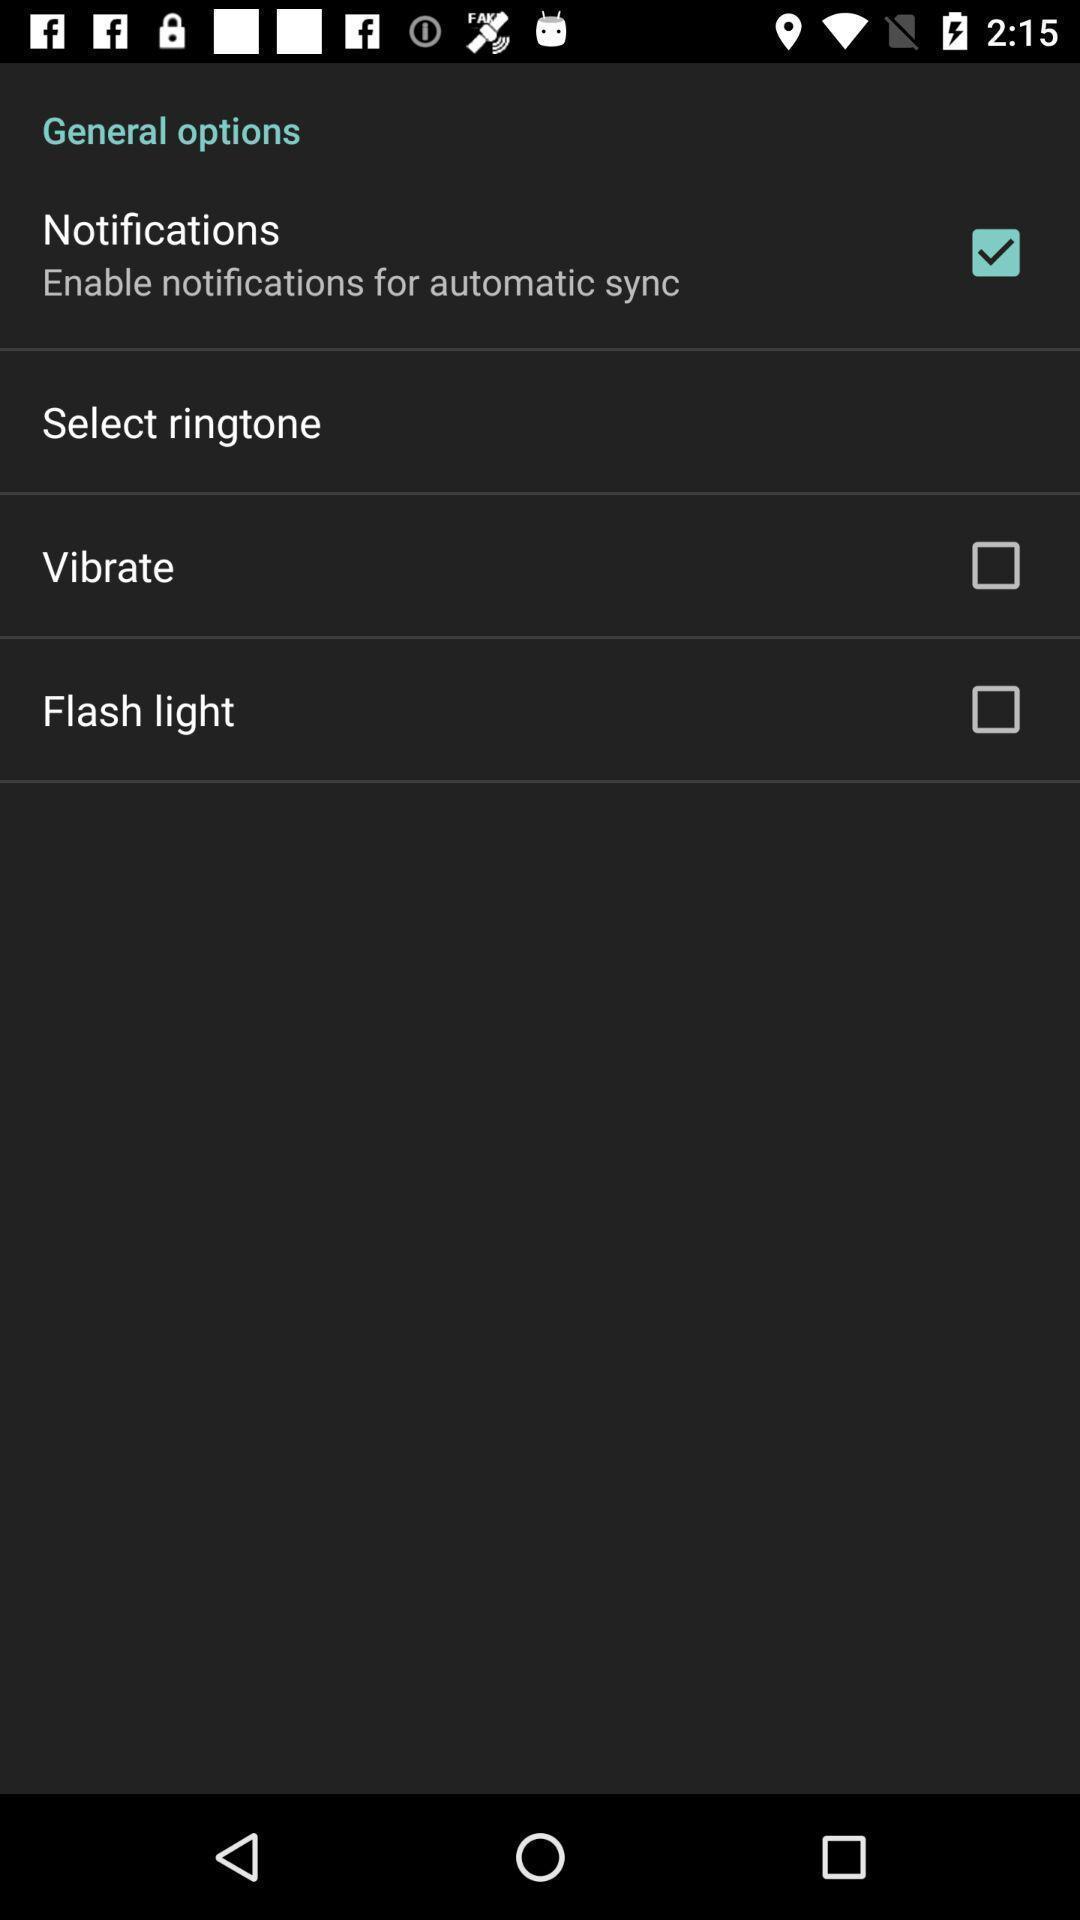Give me a summary of this screen capture. Screen displaying lift of options. 